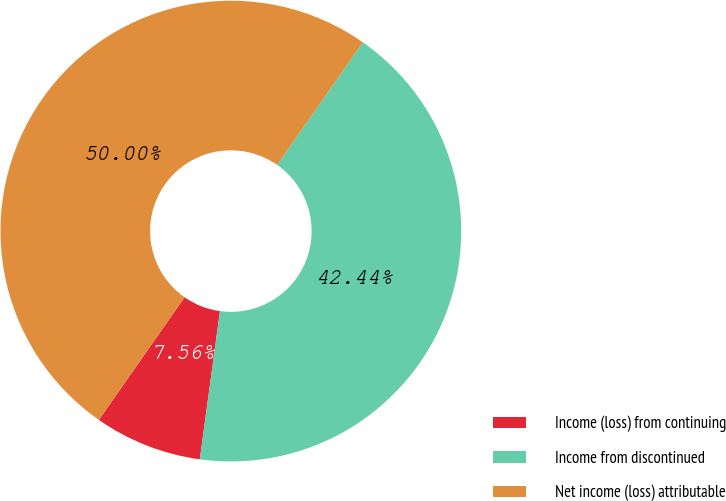Convert chart to OTSL. <chart><loc_0><loc_0><loc_500><loc_500><pie_chart><fcel>Income (loss) from continuing<fcel>Income from discontinued<fcel>Net income (loss) attributable<nl><fcel>7.56%<fcel>42.44%<fcel>50.0%<nl></chart> 